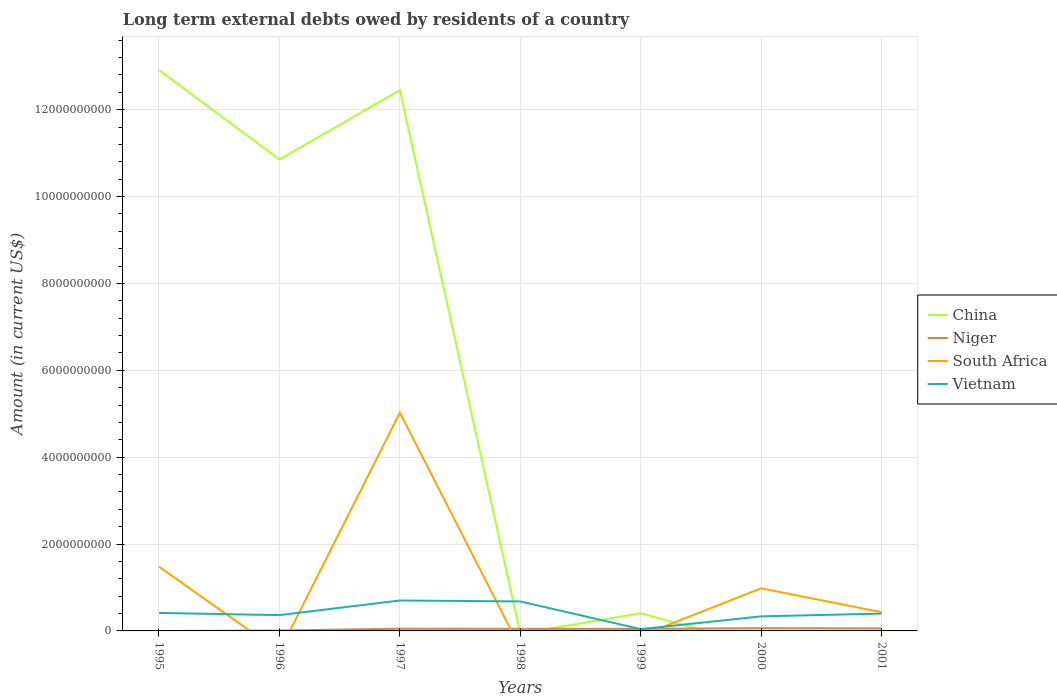How many different coloured lines are there?
Offer a terse response. 4. What is the total amount of long-term external debts owed by residents in China in the graph?
Your response must be concise. -1.60e+09. What is the difference between the highest and the second highest amount of long-term external debts owed by residents in Vietnam?
Make the answer very short. 6.59e+08. What is the difference between the highest and the lowest amount of long-term external debts owed by residents in Niger?
Provide a short and direct response. 5. How many lines are there?
Your answer should be compact. 4. Where does the legend appear in the graph?
Your answer should be compact. Center right. How many legend labels are there?
Keep it short and to the point. 4. What is the title of the graph?
Your answer should be compact. Long term external debts owed by residents of a country. Does "India" appear as one of the legend labels in the graph?
Make the answer very short. No. What is the label or title of the X-axis?
Offer a terse response. Years. What is the label or title of the Y-axis?
Offer a very short reply. Amount (in current US$). What is the Amount (in current US$) of China in 1995?
Give a very brief answer. 1.29e+1. What is the Amount (in current US$) in South Africa in 1995?
Keep it short and to the point. 1.48e+09. What is the Amount (in current US$) in Vietnam in 1995?
Provide a succinct answer. 4.14e+08. What is the Amount (in current US$) of China in 1996?
Provide a short and direct response. 1.09e+1. What is the Amount (in current US$) in Niger in 1996?
Your answer should be compact. 9.60e+06. What is the Amount (in current US$) in South Africa in 1996?
Make the answer very short. 0. What is the Amount (in current US$) in Vietnam in 1996?
Offer a terse response. 3.64e+08. What is the Amount (in current US$) of China in 1997?
Your response must be concise. 1.24e+1. What is the Amount (in current US$) in Niger in 1997?
Provide a succinct answer. 5.06e+07. What is the Amount (in current US$) of South Africa in 1997?
Provide a short and direct response. 5.02e+09. What is the Amount (in current US$) of Vietnam in 1997?
Keep it short and to the point. 7.01e+08. What is the Amount (in current US$) of Niger in 1998?
Your answer should be compact. 4.87e+07. What is the Amount (in current US$) in South Africa in 1998?
Your answer should be compact. 0. What is the Amount (in current US$) in Vietnam in 1998?
Make the answer very short. 6.79e+08. What is the Amount (in current US$) of China in 1999?
Give a very brief answer. 4.08e+08. What is the Amount (in current US$) of Niger in 1999?
Your response must be concise. 4.75e+07. What is the Amount (in current US$) of Vietnam in 1999?
Ensure brevity in your answer.  4.12e+07. What is the Amount (in current US$) in China in 2000?
Ensure brevity in your answer.  0. What is the Amount (in current US$) in Niger in 2000?
Ensure brevity in your answer.  6.21e+07. What is the Amount (in current US$) of South Africa in 2000?
Give a very brief answer. 9.80e+08. What is the Amount (in current US$) of Vietnam in 2000?
Make the answer very short. 3.35e+08. What is the Amount (in current US$) in Niger in 2001?
Give a very brief answer. 5.83e+07. What is the Amount (in current US$) of South Africa in 2001?
Your response must be concise. 4.31e+08. What is the Amount (in current US$) of Vietnam in 2001?
Offer a terse response. 3.99e+08. Across all years, what is the maximum Amount (in current US$) of China?
Provide a succinct answer. 1.29e+1. Across all years, what is the maximum Amount (in current US$) in Niger?
Provide a short and direct response. 6.21e+07. Across all years, what is the maximum Amount (in current US$) in South Africa?
Provide a short and direct response. 5.02e+09. Across all years, what is the maximum Amount (in current US$) in Vietnam?
Your response must be concise. 7.01e+08. Across all years, what is the minimum Amount (in current US$) in China?
Provide a succinct answer. 0. Across all years, what is the minimum Amount (in current US$) of Niger?
Your response must be concise. 0. Across all years, what is the minimum Amount (in current US$) in Vietnam?
Your answer should be compact. 4.12e+07. What is the total Amount (in current US$) in China in the graph?
Give a very brief answer. 3.66e+1. What is the total Amount (in current US$) in Niger in the graph?
Your answer should be compact. 2.77e+08. What is the total Amount (in current US$) of South Africa in the graph?
Offer a terse response. 7.91e+09. What is the total Amount (in current US$) in Vietnam in the graph?
Your response must be concise. 2.93e+09. What is the difference between the Amount (in current US$) in China in 1995 and that in 1996?
Your response must be concise. 2.06e+09. What is the difference between the Amount (in current US$) of Vietnam in 1995 and that in 1996?
Provide a short and direct response. 5.02e+07. What is the difference between the Amount (in current US$) in China in 1995 and that in 1997?
Offer a terse response. 4.66e+08. What is the difference between the Amount (in current US$) in South Africa in 1995 and that in 1997?
Offer a terse response. -3.55e+09. What is the difference between the Amount (in current US$) of Vietnam in 1995 and that in 1997?
Your answer should be very brief. -2.86e+08. What is the difference between the Amount (in current US$) of Vietnam in 1995 and that in 1998?
Your response must be concise. -2.65e+08. What is the difference between the Amount (in current US$) in China in 1995 and that in 1999?
Ensure brevity in your answer.  1.25e+1. What is the difference between the Amount (in current US$) in Vietnam in 1995 and that in 1999?
Give a very brief answer. 3.73e+08. What is the difference between the Amount (in current US$) in South Africa in 1995 and that in 2000?
Give a very brief answer. 4.98e+08. What is the difference between the Amount (in current US$) of Vietnam in 1995 and that in 2000?
Ensure brevity in your answer.  7.89e+07. What is the difference between the Amount (in current US$) of South Africa in 1995 and that in 2001?
Your answer should be compact. 1.05e+09. What is the difference between the Amount (in current US$) of Vietnam in 1995 and that in 2001?
Your response must be concise. 1.54e+07. What is the difference between the Amount (in current US$) in China in 1996 and that in 1997?
Offer a terse response. -1.60e+09. What is the difference between the Amount (in current US$) in Niger in 1996 and that in 1997?
Make the answer very short. -4.10e+07. What is the difference between the Amount (in current US$) in Vietnam in 1996 and that in 1997?
Your answer should be very brief. -3.37e+08. What is the difference between the Amount (in current US$) of Niger in 1996 and that in 1998?
Your answer should be very brief. -3.91e+07. What is the difference between the Amount (in current US$) in Vietnam in 1996 and that in 1998?
Provide a short and direct response. -3.15e+08. What is the difference between the Amount (in current US$) of China in 1996 and that in 1999?
Your response must be concise. 1.04e+1. What is the difference between the Amount (in current US$) in Niger in 1996 and that in 1999?
Your answer should be compact. -3.79e+07. What is the difference between the Amount (in current US$) in Vietnam in 1996 and that in 1999?
Offer a terse response. 3.23e+08. What is the difference between the Amount (in current US$) of Niger in 1996 and that in 2000?
Keep it short and to the point. -5.25e+07. What is the difference between the Amount (in current US$) in Vietnam in 1996 and that in 2000?
Your response must be concise. 2.88e+07. What is the difference between the Amount (in current US$) in Niger in 1996 and that in 2001?
Offer a very short reply. -4.87e+07. What is the difference between the Amount (in current US$) in Vietnam in 1996 and that in 2001?
Your answer should be compact. -3.48e+07. What is the difference between the Amount (in current US$) of Niger in 1997 and that in 1998?
Give a very brief answer. 1.93e+06. What is the difference between the Amount (in current US$) in Vietnam in 1997 and that in 1998?
Provide a short and direct response. 2.19e+07. What is the difference between the Amount (in current US$) of China in 1997 and that in 1999?
Make the answer very short. 1.20e+1. What is the difference between the Amount (in current US$) in Niger in 1997 and that in 1999?
Make the answer very short. 3.13e+06. What is the difference between the Amount (in current US$) of Vietnam in 1997 and that in 1999?
Offer a very short reply. 6.59e+08. What is the difference between the Amount (in current US$) of Niger in 1997 and that in 2000?
Your answer should be compact. -1.14e+07. What is the difference between the Amount (in current US$) of South Africa in 1997 and that in 2000?
Make the answer very short. 4.04e+09. What is the difference between the Amount (in current US$) of Vietnam in 1997 and that in 2000?
Your answer should be compact. 3.65e+08. What is the difference between the Amount (in current US$) of Niger in 1997 and that in 2001?
Your response must be concise. -7.61e+06. What is the difference between the Amount (in current US$) of South Africa in 1997 and that in 2001?
Provide a succinct answer. 4.59e+09. What is the difference between the Amount (in current US$) of Vietnam in 1997 and that in 2001?
Give a very brief answer. 3.02e+08. What is the difference between the Amount (in current US$) of Niger in 1998 and that in 1999?
Keep it short and to the point. 1.20e+06. What is the difference between the Amount (in current US$) of Vietnam in 1998 and that in 1999?
Keep it short and to the point. 6.37e+08. What is the difference between the Amount (in current US$) of Niger in 1998 and that in 2000?
Keep it short and to the point. -1.34e+07. What is the difference between the Amount (in current US$) in Vietnam in 1998 and that in 2000?
Provide a succinct answer. 3.43e+08. What is the difference between the Amount (in current US$) of Niger in 1998 and that in 2001?
Your response must be concise. -9.54e+06. What is the difference between the Amount (in current US$) in Vietnam in 1998 and that in 2001?
Provide a short and direct response. 2.80e+08. What is the difference between the Amount (in current US$) in Niger in 1999 and that in 2000?
Keep it short and to the point. -1.46e+07. What is the difference between the Amount (in current US$) in Vietnam in 1999 and that in 2000?
Make the answer very short. -2.94e+08. What is the difference between the Amount (in current US$) in Niger in 1999 and that in 2001?
Provide a succinct answer. -1.07e+07. What is the difference between the Amount (in current US$) of Vietnam in 1999 and that in 2001?
Make the answer very short. -3.58e+08. What is the difference between the Amount (in current US$) in Niger in 2000 and that in 2001?
Provide a short and direct response. 3.83e+06. What is the difference between the Amount (in current US$) in South Africa in 2000 and that in 2001?
Give a very brief answer. 5.50e+08. What is the difference between the Amount (in current US$) of Vietnam in 2000 and that in 2001?
Offer a very short reply. -6.36e+07. What is the difference between the Amount (in current US$) of China in 1995 and the Amount (in current US$) of Niger in 1996?
Keep it short and to the point. 1.29e+1. What is the difference between the Amount (in current US$) of China in 1995 and the Amount (in current US$) of Vietnam in 1996?
Keep it short and to the point. 1.26e+1. What is the difference between the Amount (in current US$) of South Africa in 1995 and the Amount (in current US$) of Vietnam in 1996?
Ensure brevity in your answer.  1.11e+09. What is the difference between the Amount (in current US$) in China in 1995 and the Amount (in current US$) in Niger in 1997?
Provide a short and direct response. 1.29e+1. What is the difference between the Amount (in current US$) of China in 1995 and the Amount (in current US$) of South Africa in 1997?
Provide a succinct answer. 7.89e+09. What is the difference between the Amount (in current US$) in China in 1995 and the Amount (in current US$) in Vietnam in 1997?
Your answer should be compact. 1.22e+1. What is the difference between the Amount (in current US$) of South Africa in 1995 and the Amount (in current US$) of Vietnam in 1997?
Provide a short and direct response. 7.78e+08. What is the difference between the Amount (in current US$) of China in 1995 and the Amount (in current US$) of Niger in 1998?
Your answer should be very brief. 1.29e+1. What is the difference between the Amount (in current US$) of China in 1995 and the Amount (in current US$) of Vietnam in 1998?
Offer a very short reply. 1.22e+1. What is the difference between the Amount (in current US$) of South Africa in 1995 and the Amount (in current US$) of Vietnam in 1998?
Give a very brief answer. 8.00e+08. What is the difference between the Amount (in current US$) of China in 1995 and the Amount (in current US$) of Niger in 1999?
Your response must be concise. 1.29e+1. What is the difference between the Amount (in current US$) in China in 1995 and the Amount (in current US$) in Vietnam in 1999?
Provide a short and direct response. 1.29e+1. What is the difference between the Amount (in current US$) of South Africa in 1995 and the Amount (in current US$) of Vietnam in 1999?
Provide a succinct answer. 1.44e+09. What is the difference between the Amount (in current US$) of China in 1995 and the Amount (in current US$) of Niger in 2000?
Your answer should be compact. 1.29e+1. What is the difference between the Amount (in current US$) of China in 1995 and the Amount (in current US$) of South Africa in 2000?
Provide a succinct answer. 1.19e+1. What is the difference between the Amount (in current US$) of China in 1995 and the Amount (in current US$) of Vietnam in 2000?
Keep it short and to the point. 1.26e+1. What is the difference between the Amount (in current US$) in South Africa in 1995 and the Amount (in current US$) in Vietnam in 2000?
Ensure brevity in your answer.  1.14e+09. What is the difference between the Amount (in current US$) of China in 1995 and the Amount (in current US$) of Niger in 2001?
Provide a short and direct response. 1.29e+1. What is the difference between the Amount (in current US$) of China in 1995 and the Amount (in current US$) of South Africa in 2001?
Your answer should be very brief. 1.25e+1. What is the difference between the Amount (in current US$) in China in 1995 and the Amount (in current US$) in Vietnam in 2001?
Offer a terse response. 1.25e+1. What is the difference between the Amount (in current US$) of South Africa in 1995 and the Amount (in current US$) of Vietnam in 2001?
Ensure brevity in your answer.  1.08e+09. What is the difference between the Amount (in current US$) in China in 1996 and the Amount (in current US$) in Niger in 1997?
Your answer should be very brief. 1.08e+1. What is the difference between the Amount (in current US$) of China in 1996 and the Amount (in current US$) of South Africa in 1997?
Your answer should be compact. 5.83e+09. What is the difference between the Amount (in current US$) of China in 1996 and the Amount (in current US$) of Vietnam in 1997?
Your answer should be compact. 1.02e+1. What is the difference between the Amount (in current US$) in Niger in 1996 and the Amount (in current US$) in South Africa in 1997?
Your answer should be compact. -5.01e+09. What is the difference between the Amount (in current US$) of Niger in 1996 and the Amount (in current US$) of Vietnam in 1997?
Provide a short and direct response. -6.91e+08. What is the difference between the Amount (in current US$) in China in 1996 and the Amount (in current US$) in Niger in 1998?
Offer a very short reply. 1.08e+1. What is the difference between the Amount (in current US$) in China in 1996 and the Amount (in current US$) in Vietnam in 1998?
Your answer should be compact. 1.02e+1. What is the difference between the Amount (in current US$) of Niger in 1996 and the Amount (in current US$) of Vietnam in 1998?
Offer a very short reply. -6.69e+08. What is the difference between the Amount (in current US$) in China in 1996 and the Amount (in current US$) in Niger in 1999?
Make the answer very short. 1.08e+1. What is the difference between the Amount (in current US$) in China in 1996 and the Amount (in current US$) in Vietnam in 1999?
Provide a succinct answer. 1.08e+1. What is the difference between the Amount (in current US$) in Niger in 1996 and the Amount (in current US$) in Vietnam in 1999?
Your answer should be compact. -3.16e+07. What is the difference between the Amount (in current US$) of China in 1996 and the Amount (in current US$) of Niger in 2000?
Your answer should be very brief. 1.08e+1. What is the difference between the Amount (in current US$) in China in 1996 and the Amount (in current US$) in South Africa in 2000?
Make the answer very short. 9.87e+09. What is the difference between the Amount (in current US$) in China in 1996 and the Amount (in current US$) in Vietnam in 2000?
Your answer should be very brief. 1.05e+1. What is the difference between the Amount (in current US$) in Niger in 1996 and the Amount (in current US$) in South Africa in 2000?
Ensure brevity in your answer.  -9.71e+08. What is the difference between the Amount (in current US$) in Niger in 1996 and the Amount (in current US$) in Vietnam in 2000?
Provide a short and direct response. -3.26e+08. What is the difference between the Amount (in current US$) of China in 1996 and the Amount (in current US$) of Niger in 2001?
Offer a very short reply. 1.08e+1. What is the difference between the Amount (in current US$) in China in 1996 and the Amount (in current US$) in South Africa in 2001?
Your answer should be very brief. 1.04e+1. What is the difference between the Amount (in current US$) in China in 1996 and the Amount (in current US$) in Vietnam in 2001?
Make the answer very short. 1.05e+1. What is the difference between the Amount (in current US$) in Niger in 1996 and the Amount (in current US$) in South Africa in 2001?
Your answer should be compact. -4.21e+08. What is the difference between the Amount (in current US$) of Niger in 1996 and the Amount (in current US$) of Vietnam in 2001?
Provide a short and direct response. -3.89e+08. What is the difference between the Amount (in current US$) in China in 1997 and the Amount (in current US$) in Niger in 1998?
Offer a terse response. 1.24e+1. What is the difference between the Amount (in current US$) in China in 1997 and the Amount (in current US$) in Vietnam in 1998?
Offer a terse response. 1.18e+1. What is the difference between the Amount (in current US$) in Niger in 1997 and the Amount (in current US$) in Vietnam in 1998?
Ensure brevity in your answer.  -6.28e+08. What is the difference between the Amount (in current US$) of South Africa in 1997 and the Amount (in current US$) of Vietnam in 1998?
Make the answer very short. 4.35e+09. What is the difference between the Amount (in current US$) in China in 1997 and the Amount (in current US$) in Niger in 1999?
Your response must be concise. 1.24e+1. What is the difference between the Amount (in current US$) in China in 1997 and the Amount (in current US$) in Vietnam in 1999?
Your response must be concise. 1.24e+1. What is the difference between the Amount (in current US$) of Niger in 1997 and the Amount (in current US$) of Vietnam in 1999?
Ensure brevity in your answer.  9.41e+06. What is the difference between the Amount (in current US$) in South Africa in 1997 and the Amount (in current US$) in Vietnam in 1999?
Your response must be concise. 4.98e+09. What is the difference between the Amount (in current US$) in China in 1997 and the Amount (in current US$) in Niger in 2000?
Keep it short and to the point. 1.24e+1. What is the difference between the Amount (in current US$) of China in 1997 and the Amount (in current US$) of South Africa in 2000?
Ensure brevity in your answer.  1.15e+1. What is the difference between the Amount (in current US$) in China in 1997 and the Amount (in current US$) in Vietnam in 2000?
Keep it short and to the point. 1.21e+1. What is the difference between the Amount (in current US$) in Niger in 1997 and the Amount (in current US$) in South Africa in 2000?
Provide a succinct answer. -9.30e+08. What is the difference between the Amount (in current US$) in Niger in 1997 and the Amount (in current US$) in Vietnam in 2000?
Keep it short and to the point. -2.85e+08. What is the difference between the Amount (in current US$) in South Africa in 1997 and the Amount (in current US$) in Vietnam in 2000?
Your response must be concise. 4.69e+09. What is the difference between the Amount (in current US$) in China in 1997 and the Amount (in current US$) in Niger in 2001?
Offer a very short reply. 1.24e+1. What is the difference between the Amount (in current US$) in China in 1997 and the Amount (in current US$) in South Africa in 2001?
Offer a very short reply. 1.20e+1. What is the difference between the Amount (in current US$) in China in 1997 and the Amount (in current US$) in Vietnam in 2001?
Your response must be concise. 1.21e+1. What is the difference between the Amount (in current US$) of Niger in 1997 and the Amount (in current US$) of South Africa in 2001?
Your answer should be very brief. -3.80e+08. What is the difference between the Amount (in current US$) in Niger in 1997 and the Amount (in current US$) in Vietnam in 2001?
Offer a very short reply. -3.48e+08. What is the difference between the Amount (in current US$) of South Africa in 1997 and the Amount (in current US$) of Vietnam in 2001?
Offer a terse response. 4.63e+09. What is the difference between the Amount (in current US$) in Niger in 1998 and the Amount (in current US$) in Vietnam in 1999?
Your response must be concise. 7.48e+06. What is the difference between the Amount (in current US$) of Niger in 1998 and the Amount (in current US$) of South Africa in 2000?
Your answer should be compact. -9.32e+08. What is the difference between the Amount (in current US$) in Niger in 1998 and the Amount (in current US$) in Vietnam in 2000?
Your answer should be compact. -2.86e+08. What is the difference between the Amount (in current US$) of Niger in 1998 and the Amount (in current US$) of South Africa in 2001?
Your answer should be very brief. -3.82e+08. What is the difference between the Amount (in current US$) of Niger in 1998 and the Amount (in current US$) of Vietnam in 2001?
Offer a very short reply. -3.50e+08. What is the difference between the Amount (in current US$) of China in 1999 and the Amount (in current US$) of Niger in 2000?
Your response must be concise. 3.46e+08. What is the difference between the Amount (in current US$) in China in 1999 and the Amount (in current US$) in South Africa in 2000?
Your answer should be very brief. -5.72e+08. What is the difference between the Amount (in current US$) in China in 1999 and the Amount (in current US$) in Vietnam in 2000?
Make the answer very short. 7.27e+07. What is the difference between the Amount (in current US$) of Niger in 1999 and the Amount (in current US$) of South Africa in 2000?
Offer a terse response. -9.33e+08. What is the difference between the Amount (in current US$) in Niger in 1999 and the Amount (in current US$) in Vietnam in 2000?
Provide a short and direct response. -2.88e+08. What is the difference between the Amount (in current US$) in China in 1999 and the Amount (in current US$) in Niger in 2001?
Provide a succinct answer. 3.50e+08. What is the difference between the Amount (in current US$) in China in 1999 and the Amount (in current US$) in South Africa in 2001?
Your answer should be compact. -2.28e+07. What is the difference between the Amount (in current US$) in China in 1999 and the Amount (in current US$) in Vietnam in 2001?
Keep it short and to the point. 9.16e+06. What is the difference between the Amount (in current US$) in Niger in 1999 and the Amount (in current US$) in South Africa in 2001?
Provide a succinct answer. -3.83e+08. What is the difference between the Amount (in current US$) of Niger in 1999 and the Amount (in current US$) of Vietnam in 2001?
Provide a succinct answer. -3.51e+08. What is the difference between the Amount (in current US$) in Niger in 2000 and the Amount (in current US$) in South Africa in 2001?
Your answer should be compact. -3.69e+08. What is the difference between the Amount (in current US$) in Niger in 2000 and the Amount (in current US$) in Vietnam in 2001?
Keep it short and to the point. -3.37e+08. What is the difference between the Amount (in current US$) of South Africa in 2000 and the Amount (in current US$) of Vietnam in 2001?
Make the answer very short. 5.82e+08. What is the average Amount (in current US$) of China per year?
Offer a terse response. 5.23e+09. What is the average Amount (in current US$) in Niger per year?
Make the answer very short. 3.95e+07. What is the average Amount (in current US$) of South Africa per year?
Your response must be concise. 1.13e+09. What is the average Amount (in current US$) of Vietnam per year?
Give a very brief answer. 4.19e+08. In the year 1995, what is the difference between the Amount (in current US$) of China and Amount (in current US$) of South Africa?
Ensure brevity in your answer.  1.14e+1. In the year 1995, what is the difference between the Amount (in current US$) in China and Amount (in current US$) in Vietnam?
Ensure brevity in your answer.  1.25e+1. In the year 1995, what is the difference between the Amount (in current US$) in South Africa and Amount (in current US$) in Vietnam?
Provide a succinct answer. 1.06e+09. In the year 1996, what is the difference between the Amount (in current US$) of China and Amount (in current US$) of Niger?
Offer a very short reply. 1.08e+1. In the year 1996, what is the difference between the Amount (in current US$) of China and Amount (in current US$) of Vietnam?
Keep it short and to the point. 1.05e+1. In the year 1996, what is the difference between the Amount (in current US$) of Niger and Amount (in current US$) of Vietnam?
Offer a terse response. -3.54e+08. In the year 1997, what is the difference between the Amount (in current US$) of China and Amount (in current US$) of Niger?
Keep it short and to the point. 1.24e+1. In the year 1997, what is the difference between the Amount (in current US$) of China and Amount (in current US$) of South Africa?
Give a very brief answer. 7.42e+09. In the year 1997, what is the difference between the Amount (in current US$) in China and Amount (in current US$) in Vietnam?
Your response must be concise. 1.17e+1. In the year 1997, what is the difference between the Amount (in current US$) of Niger and Amount (in current US$) of South Africa?
Provide a succinct answer. -4.97e+09. In the year 1997, what is the difference between the Amount (in current US$) of Niger and Amount (in current US$) of Vietnam?
Make the answer very short. -6.50e+08. In the year 1997, what is the difference between the Amount (in current US$) of South Africa and Amount (in current US$) of Vietnam?
Offer a terse response. 4.32e+09. In the year 1998, what is the difference between the Amount (in current US$) of Niger and Amount (in current US$) of Vietnam?
Give a very brief answer. -6.30e+08. In the year 1999, what is the difference between the Amount (in current US$) of China and Amount (in current US$) of Niger?
Keep it short and to the point. 3.60e+08. In the year 1999, what is the difference between the Amount (in current US$) in China and Amount (in current US$) in Vietnam?
Give a very brief answer. 3.67e+08. In the year 1999, what is the difference between the Amount (in current US$) of Niger and Amount (in current US$) of Vietnam?
Give a very brief answer. 6.28e+06. In the year 2000, what is the difference between the Amount (in current US$) of Niger and Amount (in current US$) of South Africa?
Your response must be concise. -9.18e+08. In the year 2000, what is the difference between the Amount (in current US$) in Niger and Amount (in current US$) in Vietnam?
Ensure brevity in your answer.  -2.73e+08. In the year 2000, what is the difference between the Amount (in current US$) of South Africa and Amount (in current US$) of Vietnam?
Provide a succinct answer. 6.45e+08. In the year 2001, what is the difference between the Amount (in current US$) in Niger and Amount (in current US$) in South Africa?
Offer a very short reply. -3.72e+08. In the year 2001, what is the difference between the Amount (in current US$) of Niger and Amount (in current US$) of Vietnam?
Your answer should be very brief. -3.41e+08. In the year 2001, what is the difference between the Amount (in current US$) in South Africa and Amount (in current US$) in Vietnam?
Your answer should be compact. 3.20e+07. What is the ratio of the Amount (in current US$) of China in 1995 to that in 1996?
Your answer should be compact. 1.19. What is the ratio of the Amount (in current US$) in Vietnam in 1995 to that in 1996?
Ensure brevity in your answer.  1.14. What is the ratio of the Amount (in current US$) in China in 1995 to that in 1997?
Your answer should be very brief. 1.04. What is the ratio of the Amount (in current US$) of South Africa in 1995 to that in 1997?
Your answer should be very brief. 0.29. What is the ratio of the Amount (in current US$) of Vietnam in 1995 to that in 1997?
Your answer should be compact. 0.59. What is the ratio of the Amount (in current US$) in Vietnam in 1995 to that in 1998?
Provide a succinct answer. 0.61. What is the ratio of the Amount (in current US$) of China in 1995 to that in 1999?
Ensure brevity in your answer.  31.66. What is the ratio of the Amount (in current US$) of Vietnam in 1995 to that in 1999?
Make the answer very short. 10.04. What is the ratio of the Amount (in current US$) of South Africa in 1995 to that in 2000?
Keep it short and to the point. 1.51. What is the ratio of the Amount (in current US$) in Vietnam in 1995 to that in 2000?
Your answer should be very brief. 1.24. What is the ratio of the Amount (in current US$) in South Africa in 1995 to that in 2001?
Give a very brief answer. 3.43. What is the ratio of the Amount (in current US$) of China in 1996 to that in 1997?
Offer a terse response. 0.87. What is the ratio of the Amount (in current US$) in Niger in 1996 to that in 1997?
Give a very brief answer. 0.19. What is the ratio of the Amount (in current US$) in Vietnam in 1996 to that in 1997?
Your answer should be compact. 0.52. What is the ratio of the Amount (in current US$) of Niger in 1996 to that in 1998?
Your answer should be very brief. 0.2. What is the ratio of the Amount (in current US$) of Vietnam in 1996 to that in 1998?
Keep it short and to the point. 0.54. What is the ratio of the Amount (in current US$) in China in 1996 to that in 1999?
Offer a very short reply. 26.61. What is the ratio of the Amount (in current US$) of Niger in 1996 to that in 1999?
Your answer should be very brief. 0.2. What is the ratio of the Amount (in current US$) in Vietnam in 1996 to that in 1999?
Your answer should be very brief. 8.83. What is the ratio of the Amount (in current US$) of Niger in 1996 to that in 2000?
Make the answer very short. 0.15. What is the ratio of the Amount (in current US$) in Vietnam in 1996 to that in 2000?
Ensure brevity in your answer.  1.09. What is the ratio of the Amount (in current US$) of Niger in 1996 to that in 2001?
Your answer should be compact. 0.16. What is the ratio of the Amount (in current US$) of Vietnam in 1996 to that in 2001?
Provide a succinct answer. 0.91. What is the ratio of the Amount (in current US$) of Niger in 1997 to that in 1998?
Offer a terse response. 1.04. What is the ratio of the Amount (in current US$) in Vietnam in 1997 to that in 1998?
Make the answer very short. 1.03. What is the ratio of the Amount (in current US$) of China in 1997 to that in 1999?
Ensure brevity in your answer.  30.52. What is the ratio of the Amount (in current US$) of Niger in 1997 to that in 1999?
Offer a terse response. 1.07. What is the ratio of the Amount (in current US$) in Vietnam in 1997 to that in 1999?
Your response must be concise. 16.99. What is the ratio of the Amount (in current US$) of Niger in 1997 to that in 2000?
Your response must be concise. 0.82. What is the ratio of the Amount (in current US$) of South Africa in 1997 to that in 2000?
Provide a succinct answer. 5.13. What is the ratio of the Amount (in current US$) of Vietnam in 1997 to that in 2000?
Make the answer very short. 2.09. What is the ratio of the Amount (in current US$) in Niger in 1997 to that in 2001?
Offer a terse response. 0.87. What is the ratio of the Amount (in current US$) in South Africa in 1997 to that in 2001?
Provide a short and direct response. 11.66. What is the ratio of the Amount (in current US$) of Vietnam in 1997 to that in 2001?
Your answer should be compact. 1.76. What is the ratio of the Amount (in current US$) in Niger in 1998 to that in 1999?
Provide a succinct answer. 1.03. What is the ratio of the Amount (in current US$) in Vietnam in 1998 to that in 1999?
Your answer should be compact. 16.46. What is the ratio of the Amount (in current US$) of Niger in 1998 to that in 2000?
Ensure brevity in your answer.  0.78. What is the ratio of the Amount (in current US$) in Vietnam in 1998 to that in 2000?
Offer a very short reply. 2.02. What is the ratio of the Amount (in current US$) of Niger in 1998 to that in 2001?
Offer a terse response. 0.84. What is the ratio of the Amount (in current US$) in Vietnam in 1998 to that in 2001?
Provide a short and direct response. 1.7. What is the ratio of the Amount (in current US$) of Niger in 1999 to that in 2000?
Ensure brevity in your answer.  0.77. What is the ratio of the Amount (in current US$) of Vietnam in 1999 to that in 2000?
Give a very brief answer. 0.12. What is the ratio of the Amount (in current US$) of Niger in 1999 to that in 2001?
Provide a succinct answer. 0.82. What is the ratio of the Amount (in current US$) in Vietnam in 1999 to that in 2001?
Make the answer very short. 0.1. What is the ratio of the Amount (in current US$) of Niger in 2000 to that in 2001?
Ensure brevity in your answer.  1.07. What is the ratio of the Amount (in current US$) in South Africa in 2000 to that in 2001?
Make the answer very short. 2.28. What is the ratio of the Amount (in current US$) in Vietnam in 2000 to that in 2001?
Provide a succinct answer. 0.84. What is the difference between the highest and the second highest Amount (in current US$) in China?
Make the answer very short. 4.66e+08. What is the difference between the highest and the second highest Amount (in current US$) of Niger?
Provide a short and direct response. 3.83e+06. What is the difference between the highest and the second highest Amount (in current US$) in South Africa?
Give a very brief answer. 3.55e+09. What is the difference between the highest and the second highest Amount (in current US$) of Vietnam?
Provide a short and direct response. 2.19e+07. What is the difference between the highest and the lowest Amount (in current US$) in China?
Give a very brief answer. 1.29e+1. What is the difference between the highest and the lowest Amount (in current US$) of Niger?
Provide a succinct answer. 6.21e+07. What is the difference between the highest and the lowest Amount (in current US$) of South Africa?
Keep it short and to the point. 5.02e+09. What is the difference between the highest and the lowest Amount (in current US$) in Vietnam?
Provide a succinct answer. 6.59e+08. 